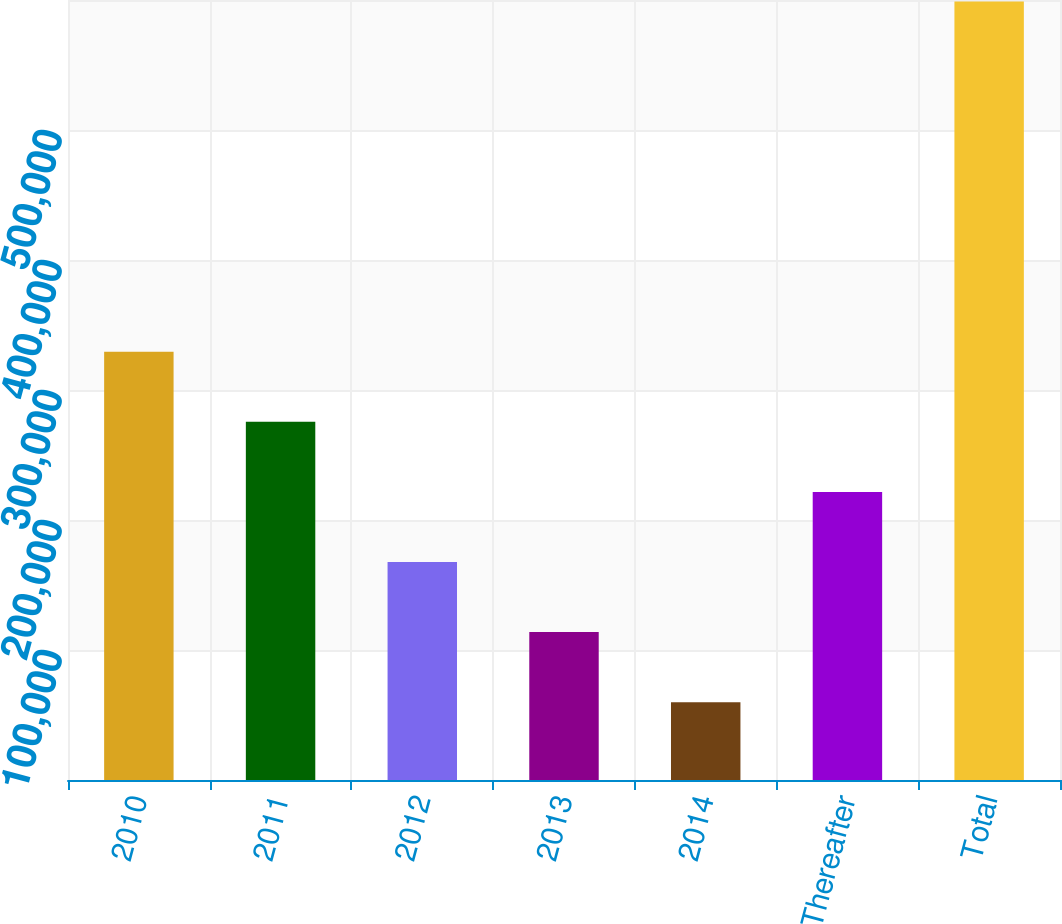<chart> <loc_0><loc_0><loc_500><loc_500><bar_chart><fcel>2010<fcel>2011<fcel>2012<fcel>2013<fcel>2014<fcel>Thereafter<fcel>Total<nl><fcel>329394<fcel>275490<fcel>167683<fcel>113779<fcel>59875<fcel>221586<fcel>598913<nl></chart> 